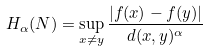Convert formula to latex. <formula><loc_0><loc_0><loc_500><loc_500>H _ { \alpha } ( N ) = \sup _ { x \ne y } \frac { | f ( x ) - f ( y ) | } { d ( x , y ) ^ { \alpha } }</formula> 